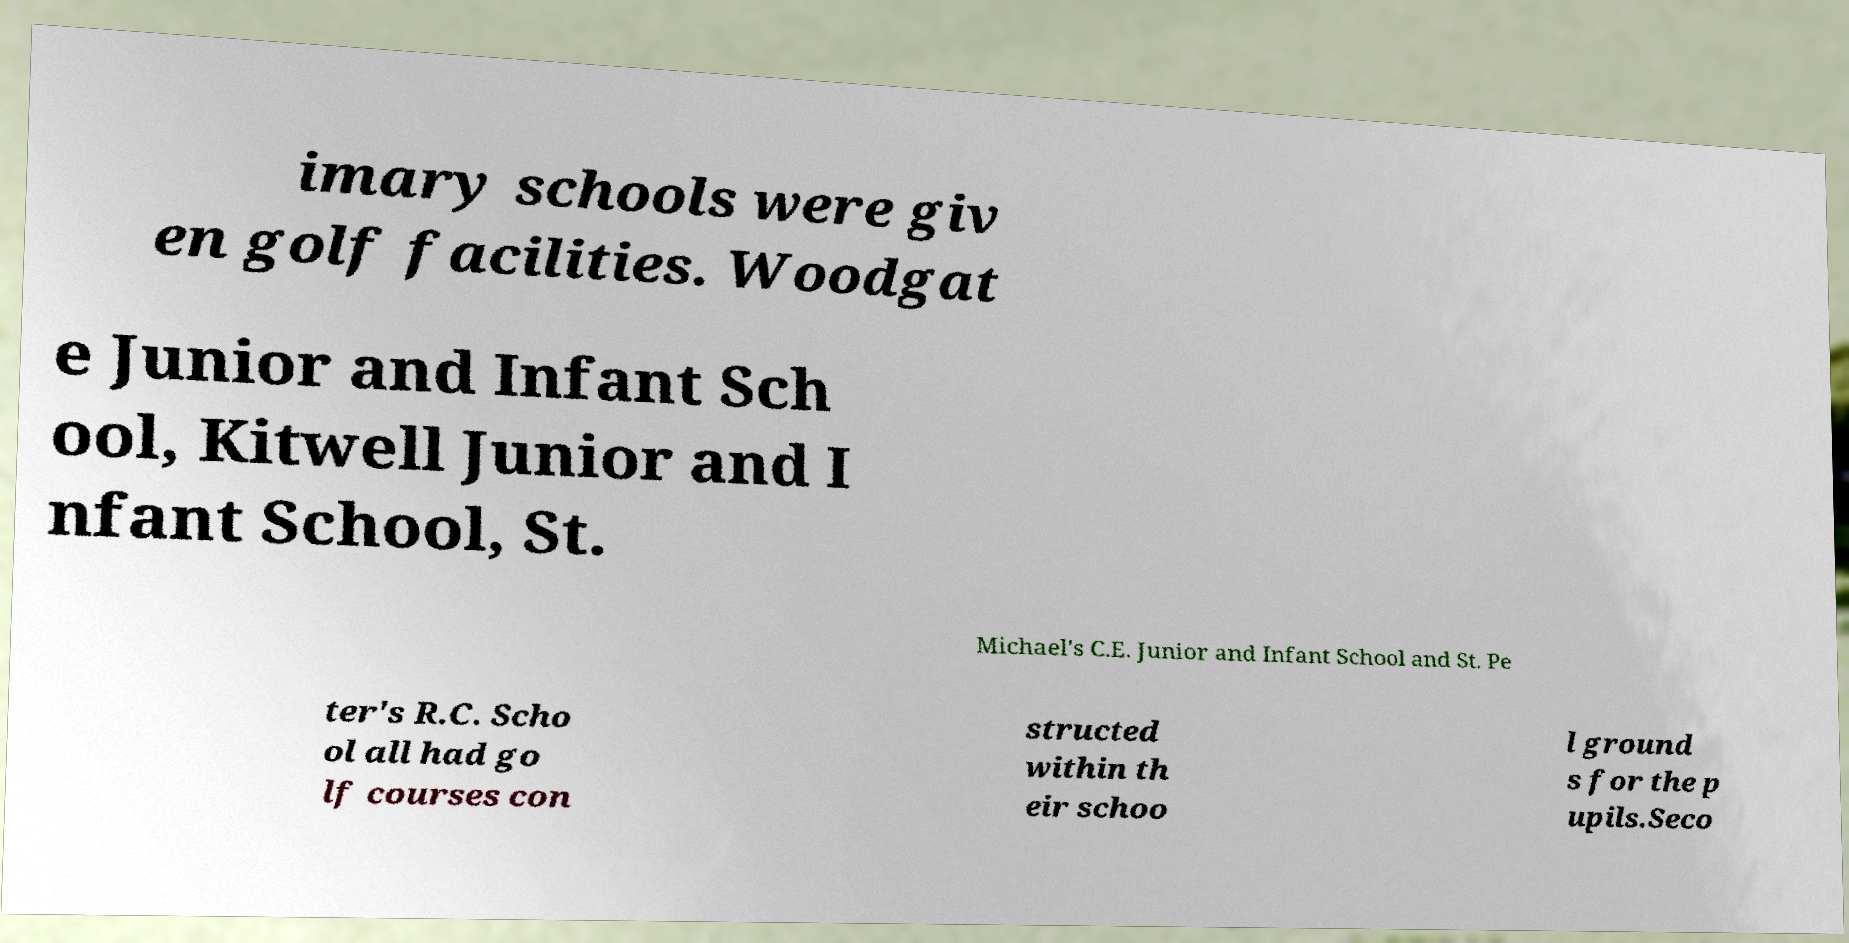Could you assist in decoding the text presented in this image and type it out clearly? imary schools were giv en golf facilities. Woodgat e Junior and Infant Sch ool, Kitwell Junior and I nfant School, St. Michael's C.E. Junior and Infant School and St. Pe ter's R.C. Scho ol all had go lf courses con structed within th eir schoo l ground s for the p upils.Seco 